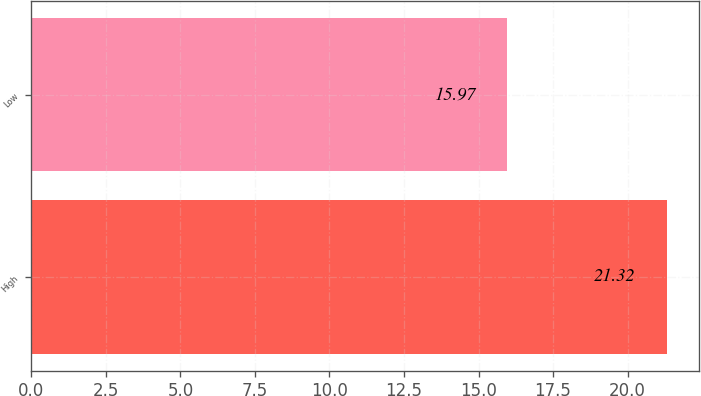<chart> <loc_0><loc_0><loc_500><loc_500><bar_chart><fcel>High<fcel>Low<nl><fcel>21.32<fcel>15.97<nl></chart> 